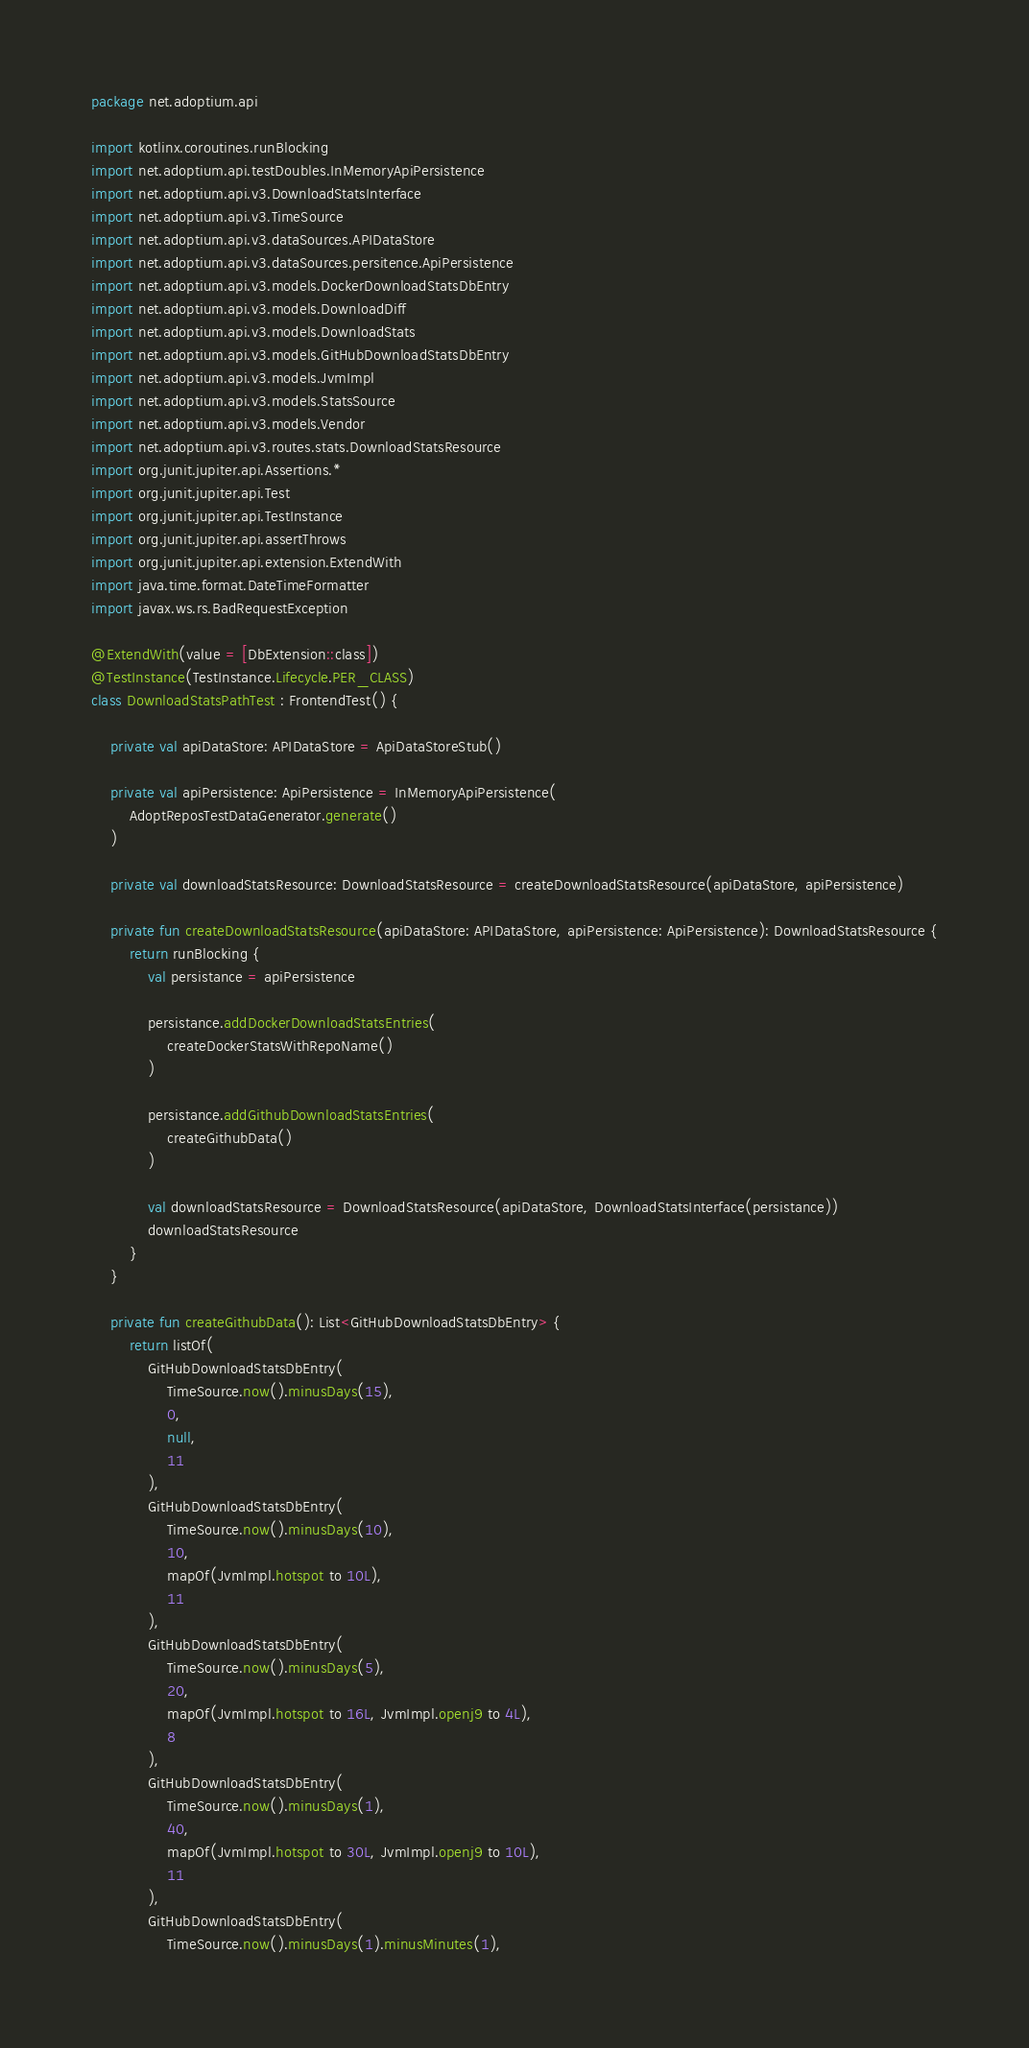<code> <loc_0><loc_0><loc_500><loc_500><_Kotlin_>package net.adoptium.api

import kotlinx.coroutines.runBlocking
import net.adoptium.api.testDoubles.InMemoryApiPersistence
import net.adoptium.api.v3.DownloadStatsInterface
import net.adoptium.api.v3.TimeSource
import net.adoptium.api.v3.dataSources.APIDataStore
import net.adoptium.api.v3.dataSources.persitence.ApiPersistence
import net.adoptium.api.v3.models.DockerDownloadStatsDbEntry
import net.adoptium.api.v3.models.DownloadDiff
import net.adoptium.api.v3.models.DownloadStats
import net.adoptium.api.v3.models.GitHubDownloadStatsDbEntry
import net.adoptium.api.v3.models.JvmImpl
import net.adoptium.api.v3.models.StatsSource
import net.adoptium.api.v3.models.Vendor
import net.adoptium.api.v3.routes.stats.DownloadStatsResource
import org.junit.jupiter.api.Assertions.*
import org.junit.jupiter.api.Test
import org.junit.jupiter.api.TestInstance
import org.junit.jupiter.api.assertThrows
import org.junit.jupiter.api.extension.ExtendWith
import java.time.format.DateTimeFormatter
import javax.ws.rs.BadRequestException

@ExtendWith(value = [DbExtension::class])
@TestInstance(TestInstance.Lifecycle.PER_CLASS)
class DownloadStatsPathTest : FrontendTest() {

    private val apiDataStore: APIDataStore = ApiDataStoreStub()

    private val apiPersistence: ApiPersistence = InMemoryApiPersistence(
        AdoptReposTestDataGenerator.generate()
    )

    private val downloadStatsResource: DownloadStatsResource = createDownloadStatsResource(apiDataStore, apiPersistence)

    private fun createDownloadStatsResource(apiDataStore: APIDataStore, apiPersistence: ApiPersistence): DownloadStatsResource {
        return runBlocking {
            val persistance = apiPersistence

            persistance.addDockerDownloadStatsEntries(
                createDockerStatsWithRepoName()
            )

            persistance.addGithubDownloadStatsEntries(
                createGithubData()
            )

            val downloadStatsResource = DownloadStatsResource(apiDataStore, DownloadStatsInterface(persistance))
            downloadStatsResource
        }
    }

    private fun createGithubData(): List<GitHubDownloadStatsDbEntry> {
        return listOf(
            GitHubDownloadStatsDbEntry(
                TimeSource.now().minusDays(15),
                0,
                null,
                11
            ),
            GitHubDownloadStatsDbEntry(
                TimeSource.now().minusDays(10),
                10,
                mapOf(JvmImpl.hotspot to 10L),
                11
            ),
            GitHubDownloadStatsDbEntry(
                TimeSource.now().minusDays(5),
                20,
                mapOf(JvmImpl.hotspot to 16L, JvmImpl.openj9 to 4L),
                8
            ),
            GitHubDownloadStatsDbEntry(
                TimeSource.now().minusDays(1),
                40,
                mapOf(JvmImpl.hotspot to 30L, JvmImpl.openj9 to 10L),
                11
            ),
            GitHubDownloadStatsDbEntry(
                TimeSource.now().minusDays(1).minusMinutes(1),</code> 